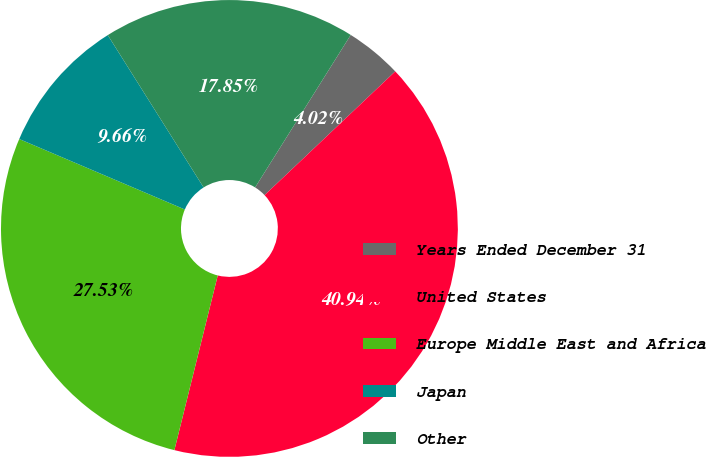Convert chart. <chart><loc_0><loc_0><loc_500><loc_500><pie_chart><fcel>Years Ended December 31<fcel>United States<fcel>Europe Middle East and Africa<fcel>Japan<fcel>Other<nl><fcel>4.02%<fcel>40.94%<fcel>27.53%<fcel>9.66%<fcel>17.85%<nl></chart> 